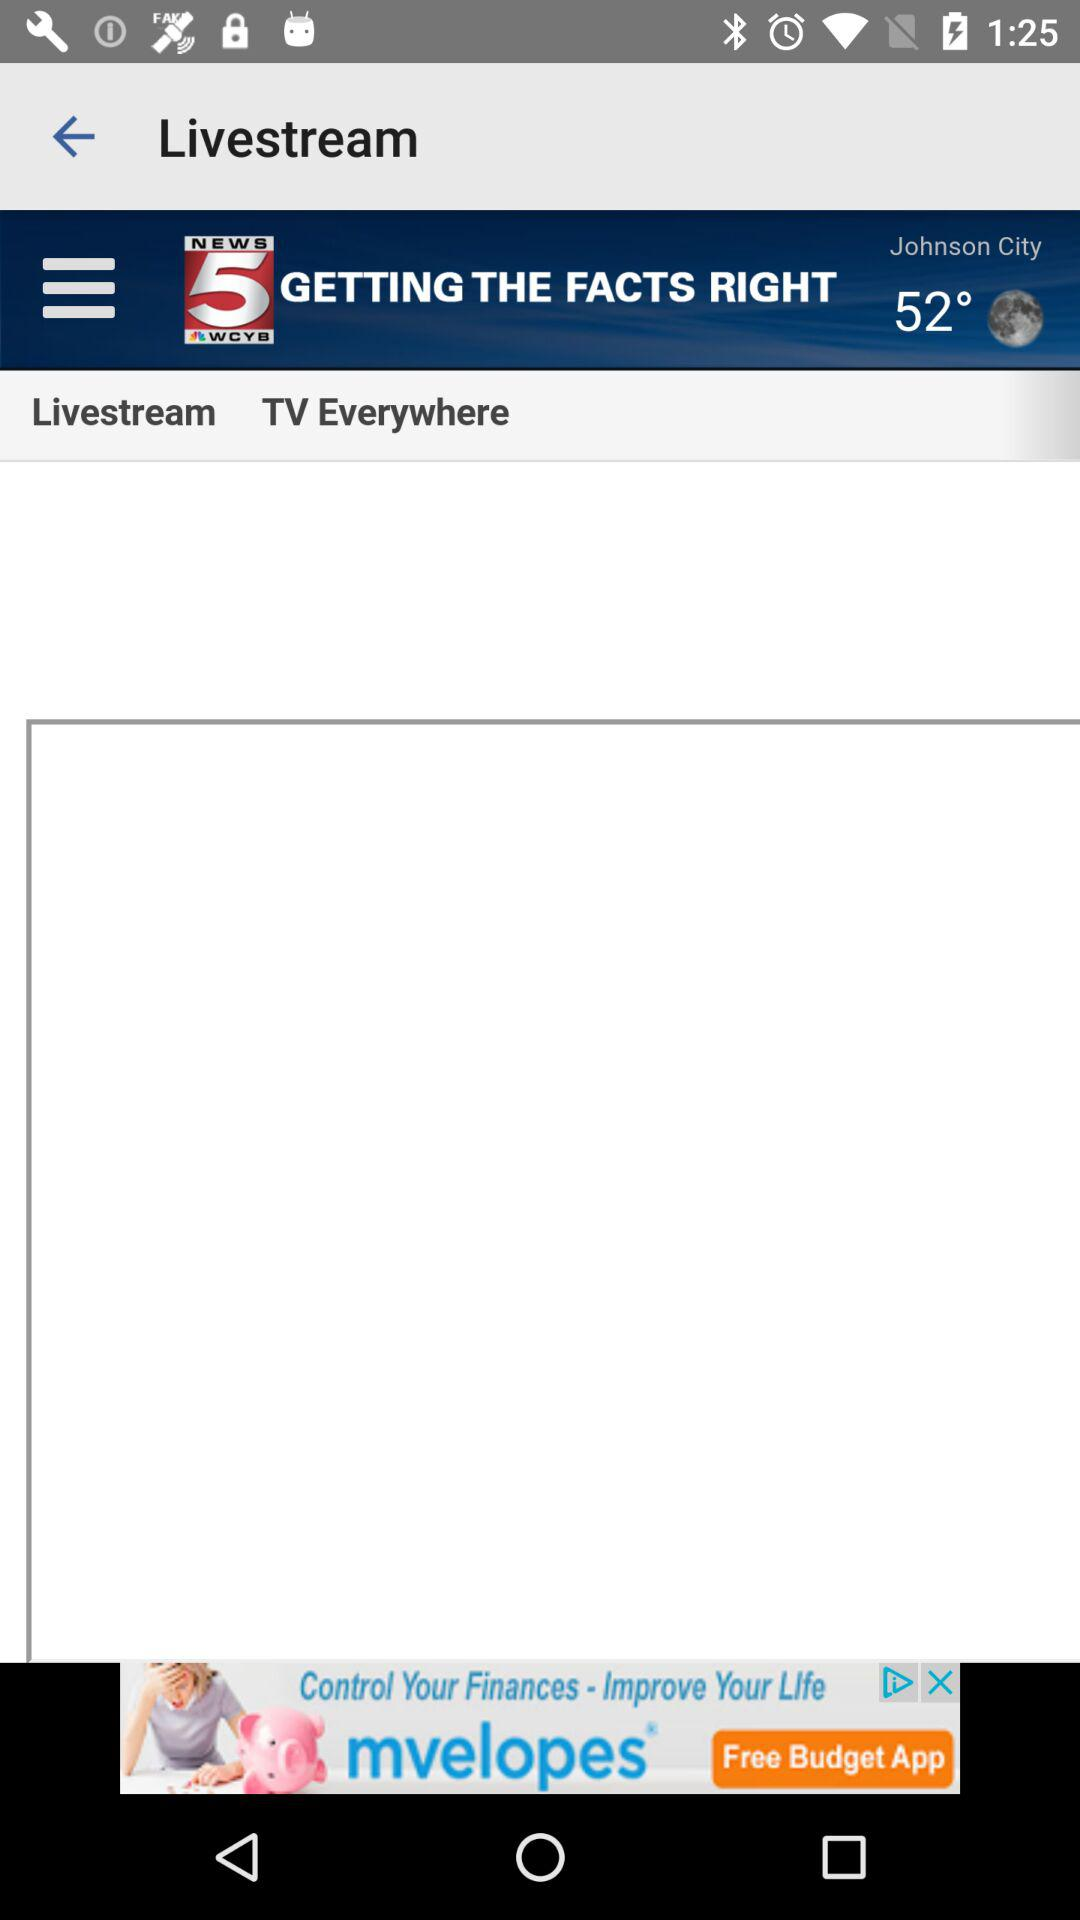What is the temperature? The temperature is 52°. 